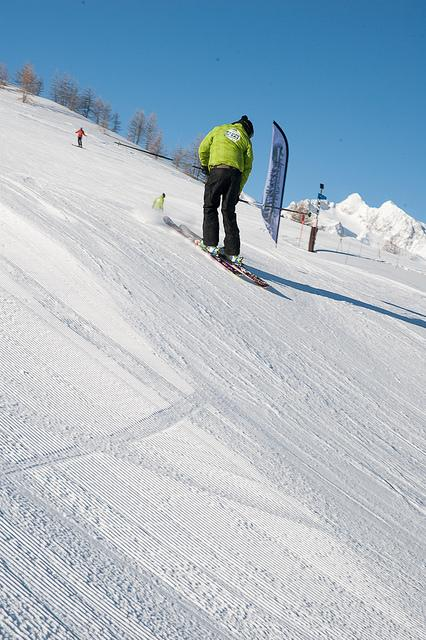What is this sport name? Please explain your reasoning. skiing. The sport name is skiing. 